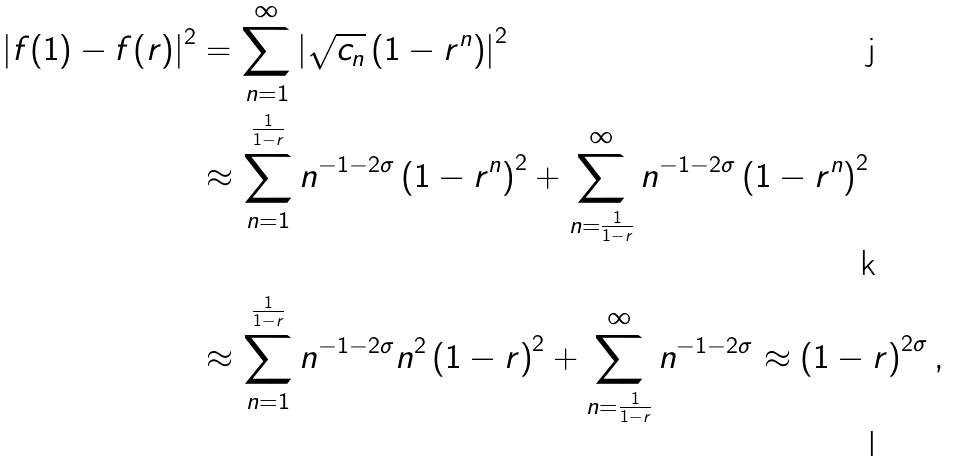Convert formula to latex. <formula><loc_0><loc_0><loc_500><loc_500>\left | f ( 1 ) - f ( r ) \right | ^ { 2 } & = \sum _ { n = 1 } ^ { \infty } \left | \sqrt { c _ { n } } \left ( 1 - r ^ { n } \right ) \right | ^ { 2 } \\ & \approx \sum _ { n = 1 } ^ { \frac { 1 } { 1 - r } } n ^ { - 1 - 2 \sigma } \left ( 1 - r ^ { n } \right ) ^ { 2 } + \sum _ { n = \frac { 1 } { 1 - r } } ^ { \infty } n ^ { - 1 - 2 \sigma } \left ( 1 - r ^ { n } \right ) ^ { 2 } \\ & \approx \sum _ { n = 1 } ^ { \frac { 1 } { 1 - r } } n ^ { - 1 - 2 \sigma } n ^ { 2 } \left ( 1 - r \right ) ^ { 2 } + \sum _ { n = \frac { 1 } { 1 - r } } ^ { \infty } n ^ { - 1 - 2 \sigma } \approx \left ( 1 - r \right ) ^ { 2 \sigma } ,</formula> 